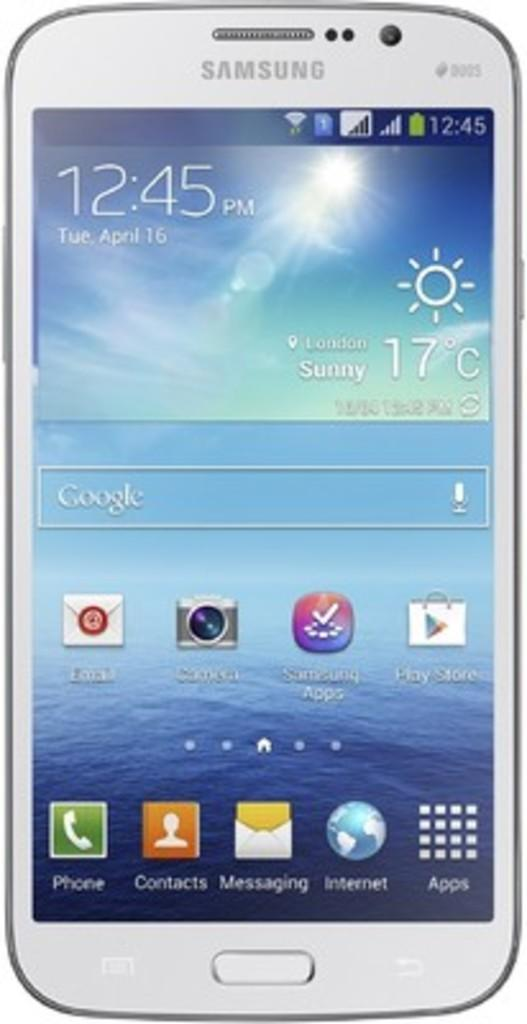<image>
Give a short and clear explanation of the subsequent image. A Samsung smart phone that is open to the home page. 